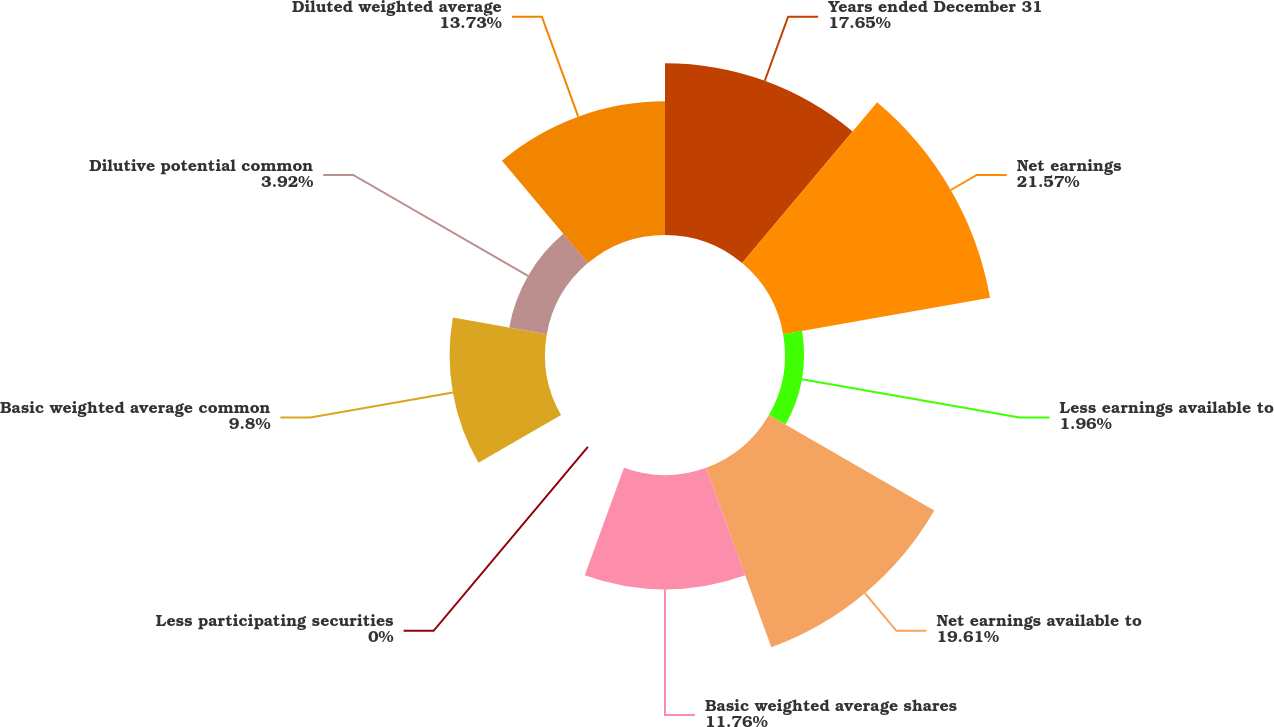Convert chart to OTSL. <chart><loc_0><loc_0><loc_500><loc_500><pie_chart><fcel>Years ended December 31<fcel>Net earnings<fcel>Less earnings available to<fcel>Net earnings available to<fcel>Basic weighted average shares<fcel>Less participating securities<fcel>Basic weighted average common<fcel>Dilutive potential common<fcel>Diluted weighted average<nl><fcel>17.65%<fcel>21.57%<fcel>1.96%<fcel>19.61%<fcel>11.76%<fcel>0.0%<fcel>9.8%<fcel>3.92%<fcel>13.73%<nl></chart> 